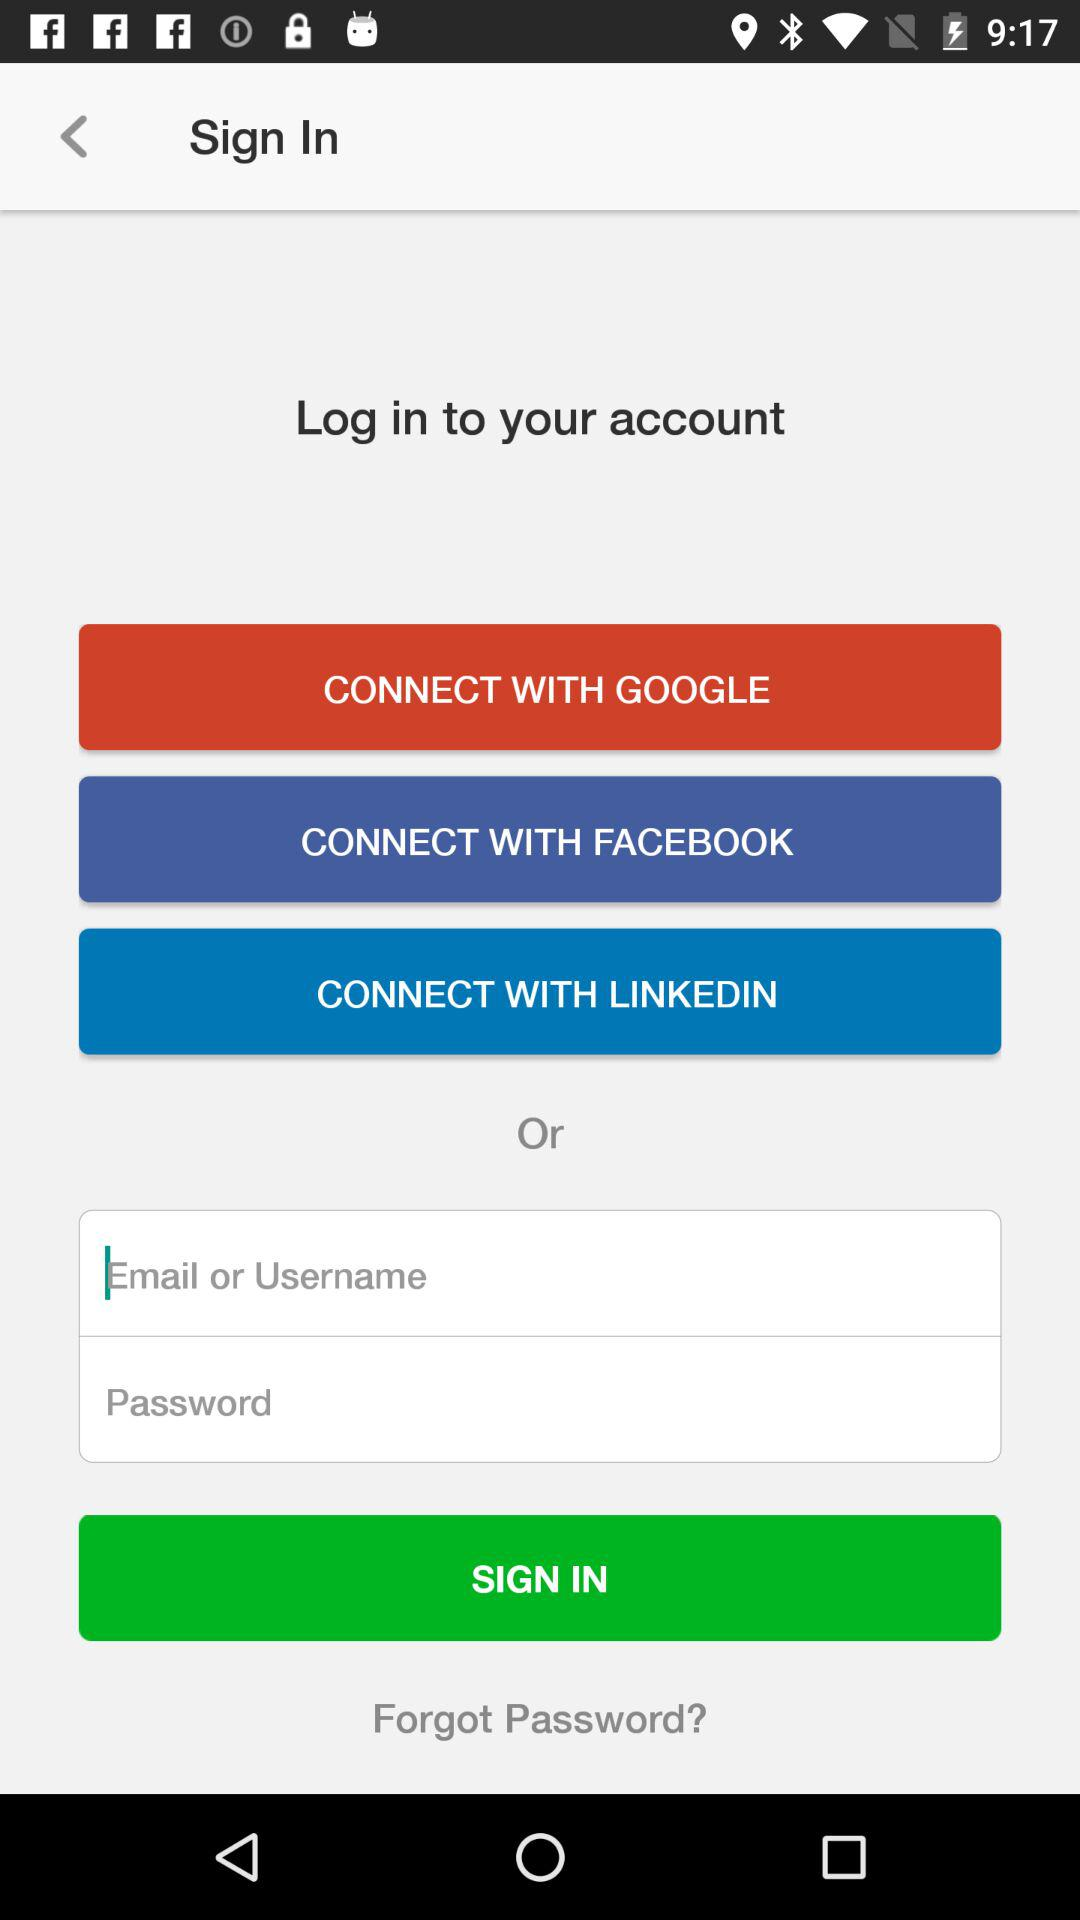How many social login options are there?
Answer the question using a single word or phrase. 3 